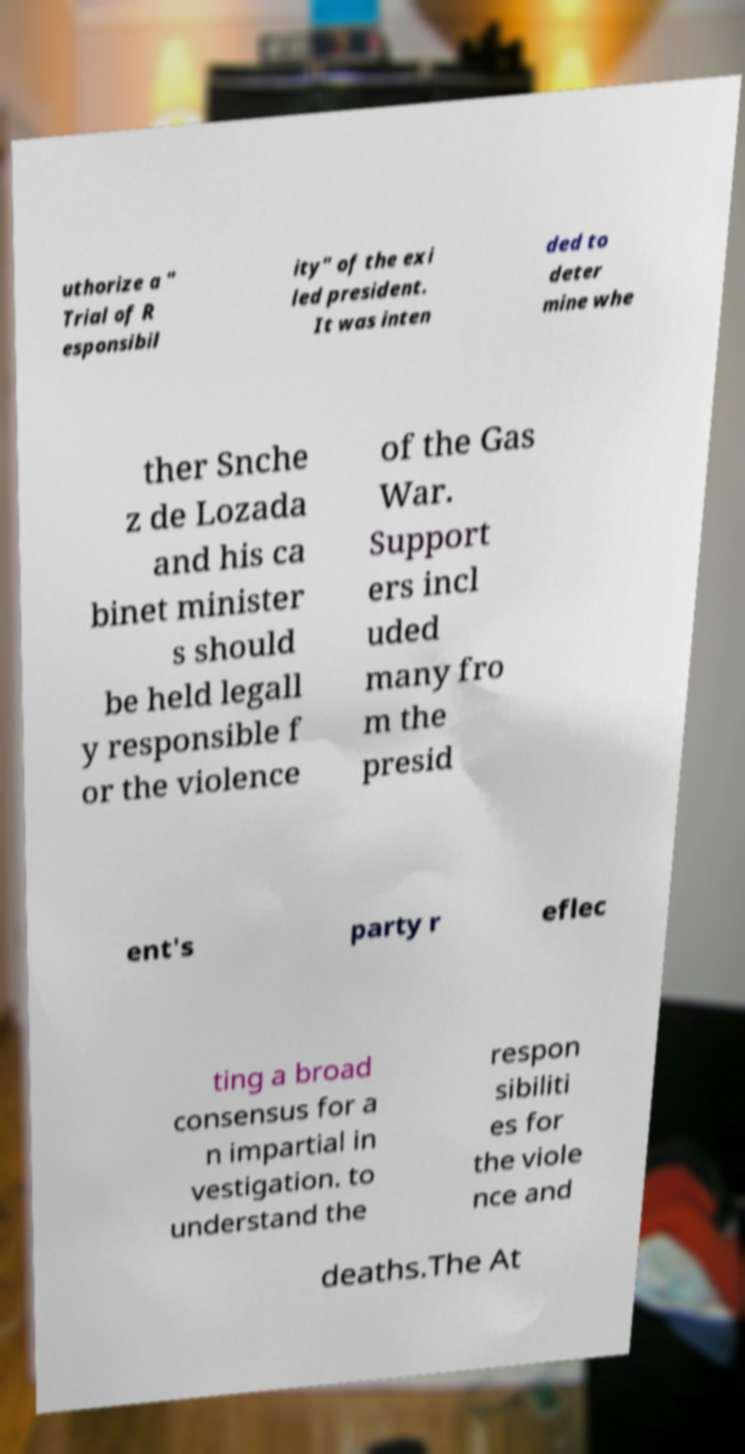What messages or text are displayed in this image? I need them in a readable, typed format. uthorize a " Trial of R esponsibil ity" of the exi led president. It was inten ded to deter mine whe ther Snche z de Lozada and his ca binet minister s should be held legall y responsible f or the violence of the Gas War. Support ers incl uded many fro m the presid ent's party r eflec ting a broad consensus for a n impartial in vestigation. to understand the respon sibiliti es for the viole nce and deaths.The At 